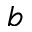<formula> <loc_0><loc_0><loc_500><loc_500>b</formula> 